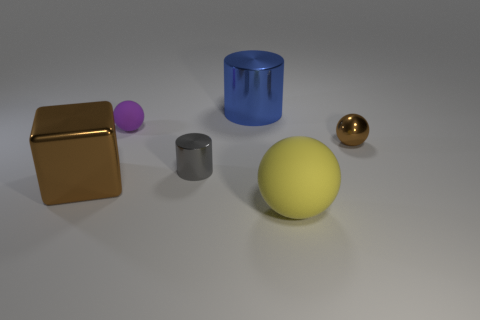How many brown cylinders have the same size as the purple thing?
Make the answer very short. 0. What is the size of the thing that is the same color as the tiny shiny sphere?
Provide a succinct answer. Large. Are there any metal objects of the same color as the large matte object?
Make the answer very short. No. The cube that is the same size as the yellow matte thing is what color?
Keep it short and to the point. Brown. There is a large cube; is its color the same as the metal thing to the right of the blue cylinder?
Offer a very short reply. Yes. What color is the tiny metal cylinder?
Make the answer very short. Gray. What is the sphere that is on the left side of the big rubber sphere made of?
Provide a short and direct response. Rubber. There is a yellow matte thing that is the same shape as the purple matte object; what is its size?
Provide a succinct answer. Large. Are there fewer tiny purple rubber things on the left side of the big brown metal cube than small blue metallic balls?
Ensure brevity in your answer.  No. Are there any large spheres?
Keep it short and to the point. Yes. 